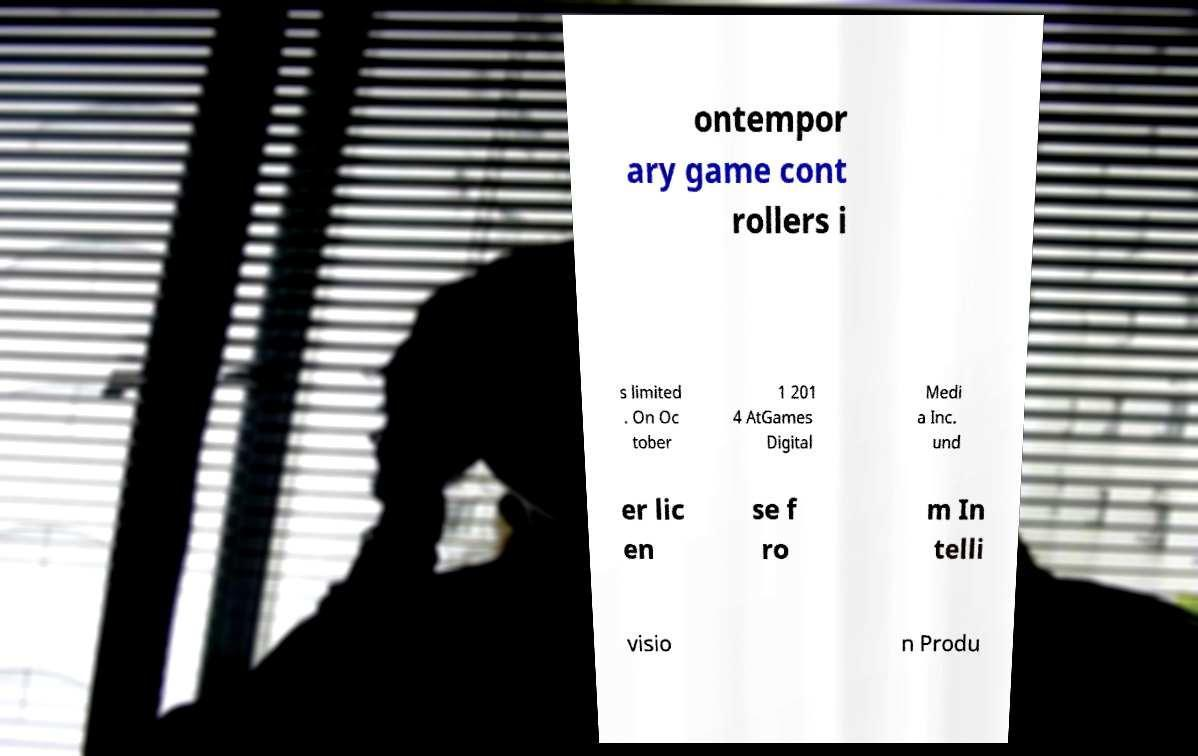Can you accurately transcribe the text from the provided image for me? ontempor ary game cont rollers i s limited . On Oc tober 1 201 4 AtGames Digital Medi a Inc. und er lic en se f ro m In telli visio n Produ 